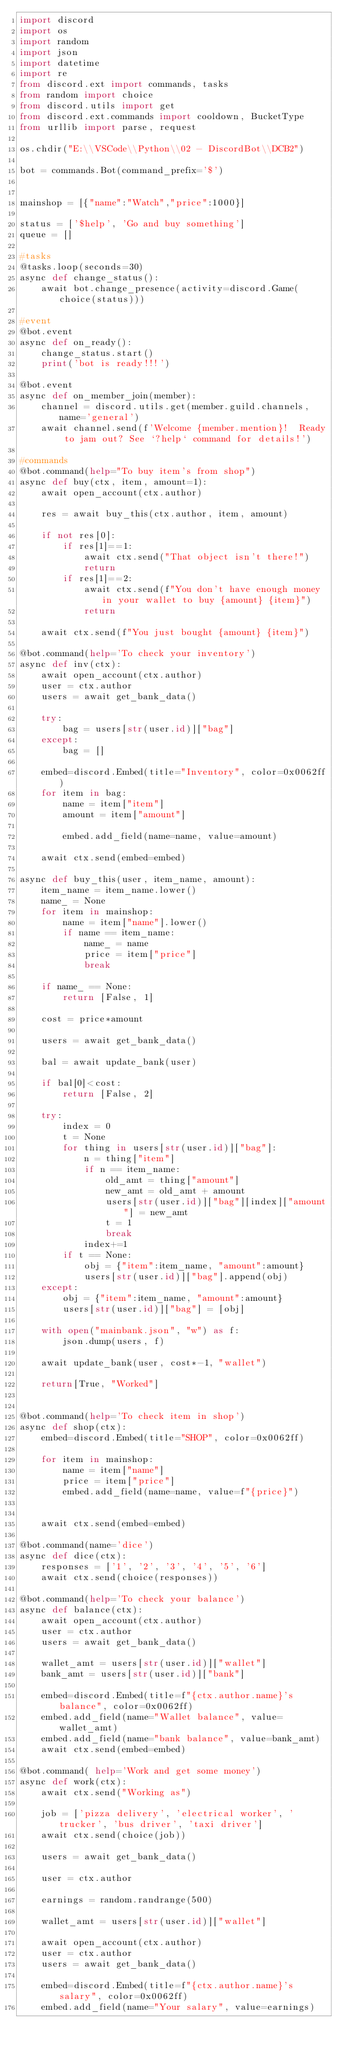<code> <loc_0><loc_0><loc_500><loc_500><_Python_>import discord
import os
import random
import json
import datetime
import re
from discord.ext import commands, tasks
from random import choice
from discord.utils import get
from discord.ext.commands import cooldown, BucketType
from urllib import parse, request

os.chdir("E:\\VSCode\\Python\\02 - DiscordBot\\DCB2")

bot = commands.Bot(command_prefix='$')


mainshop = [{"name":"Watch","price":1000}]

status = ['$help', 'Go and buy something']
queue = []

#tasks
@tasks.loop(seconds=30)
async def change_status():
    await bot.change_presence(activity=discord.Game(choice(status)))

#event
@bot.event
async def on_ready():
    change_status.start()
    print('bot is ready!!!')

@bot.event
async def on_member_join(member):
    channel = discord.utils.get(member.guild.channels, name='general')
    await channel.send(f'Welcome {member.mention}!  Ready to jam out? See `?help` command for details!')

#commands
@bot.command(help="To buy item's from shop")
async def buy(ctx, item, amount=1):
    await open_account(ctx.author)

    res = await buy_this(ctx.author, item, amount)

    if not res[0]:
        if res[1]==1:
            await ctx.send("That object isn't there!")
            return
        if res[1]==2:
            await ctx.send(f"You don't have enough money in your wallet to buy {amount} {item}")
            return
    
    await ctx.send(f"You just bought {amount} {item}")

@bot.command(help='To check your inventory')
async def inv(ctx):
    await open_account(ctx.author)
    user = ctx.author
    users = await get_bank_data()

    try:
        bag = users[str(user.id)]["bag"]
    except:
        bag = []

    embed=discord.Embed(title="Inventory", color=0x0062ff)
    for item in bag:
        name = item["item"]
        amount = item["amount"]

        embed.add_field(name=name, value=amount)

    await ctx.send(embed=embed)

async def buy_this(user, item_name, amount):
    item_name = item_name.lower()
    name_ = None
    for item in mainshop:
        name = item["name"].lower()
        if name == item_name:
            name_ = name
            price = item["price"]
            break

    if name_ == None:
        return [False, 1]

    cost = price*amount

    users = await get_bank_data()

    bal = await update_bank(user)

    if bal[0]<cost:
        return [False, 2]

    try:
        index = 0
        t = None
        for thing in users[str(user.id)]["bag"]:
            n = thing["item"]
            if n == item_name:
                old_amt = thing["amount"]
                new_amt = old_amt + amount
                users[str(user.id)]["bag"][index]["amount"] = new_amt
                t = 1
                break
            index+=1
        if t == None:
            obj = {"item":item_name, "amount":amount}
            users[str(user.id)]["bag"].append(obj)
    except:
        obj = {"item":item_name, "amount":amount}
        users[str(user.id)]["bag"] = [obj]

    with open("mainbank.json", "w") as f:
        json.dump(users, f)

    await update_bank(user, cost*-1, "wallet")

    return[True, "Worked"]


@bot.command(help='To check item in shop')
async def shop(ctx):
    embed=discord.Embed(title="SHOP", color=0x0062ff)

    for item in mainshop:
        name = item["name"]
        price = item["price"]
        embed.add_field(name=name, value=f"{price}")


    await ctx.send(embed=embed)

@bot.command(name='dice')
async def dice(ctx):
    responses = ['1', '2', '3', '4', '5', '6']
    await ctx.send(choice(responses))

@bot.command(help='To check your balance')
async def balance(ctx):
    await open_account(ctx.author)
    user = ctx.author
    users = await get_bank_data()

    wallet_amt = users[str(user.id)]["wallet"]
    bank_amt = users[str(user.id)]["bank"]

    embed=discord.Embed(title=f"{ctx.author.name}'s balance", color=0x0062ff)
    embed.add_field(name="Wallet balance", value=wallet_amt)
    embed.add_field(name="bank balance", value=bank_amt)
    await ctx.send(embed=embed)

@bot.command( help='Work and get some money')
async def work(ctx):
    await ctx.send("Working as")

    job = ['pizza delivery', 'electrical worker', 'trucker', 'bus driver', 'taxi driver']
    await ctx.send(choice(job))

    users = await get_bank_data()

    user = ctx.author

    earnings = random.randrange(500)

    wallet_amt = users[str(user.id)]["wallet"]

    await open_account(ctx.author)
    user = ctx.author
    users = await get_bank_data()

    embed=discord.Embed(title=f"{ctx.author.name}'s salary", color=0x0062ff)
    embed.add_field(name="Your salary", value=earnings)</code> 